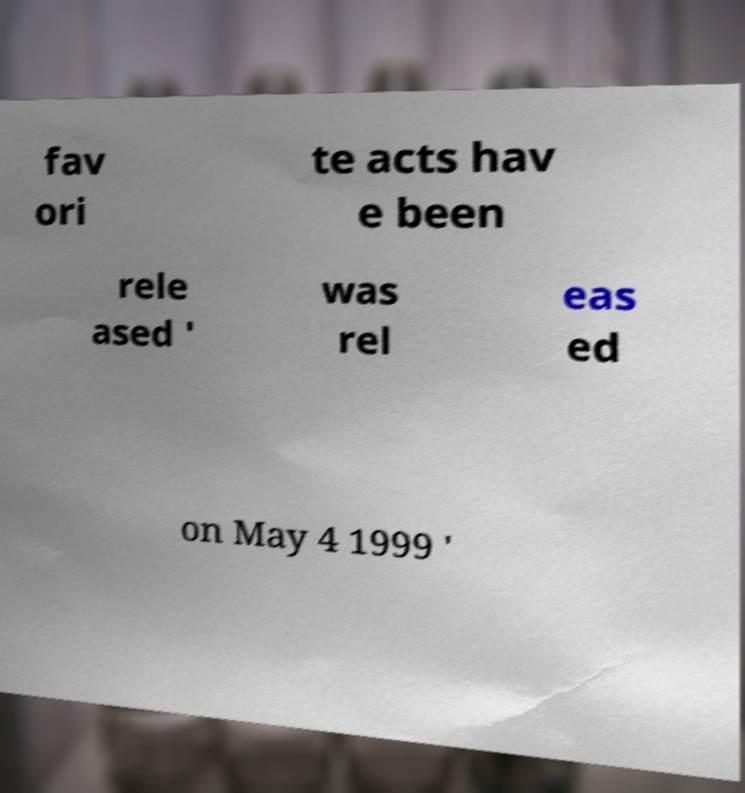Could you assist in decoding the text presented in this image and type it out clearly? fav ori te acts hav e been rele ased ' was rel eas ed on May 4 1999 ' 